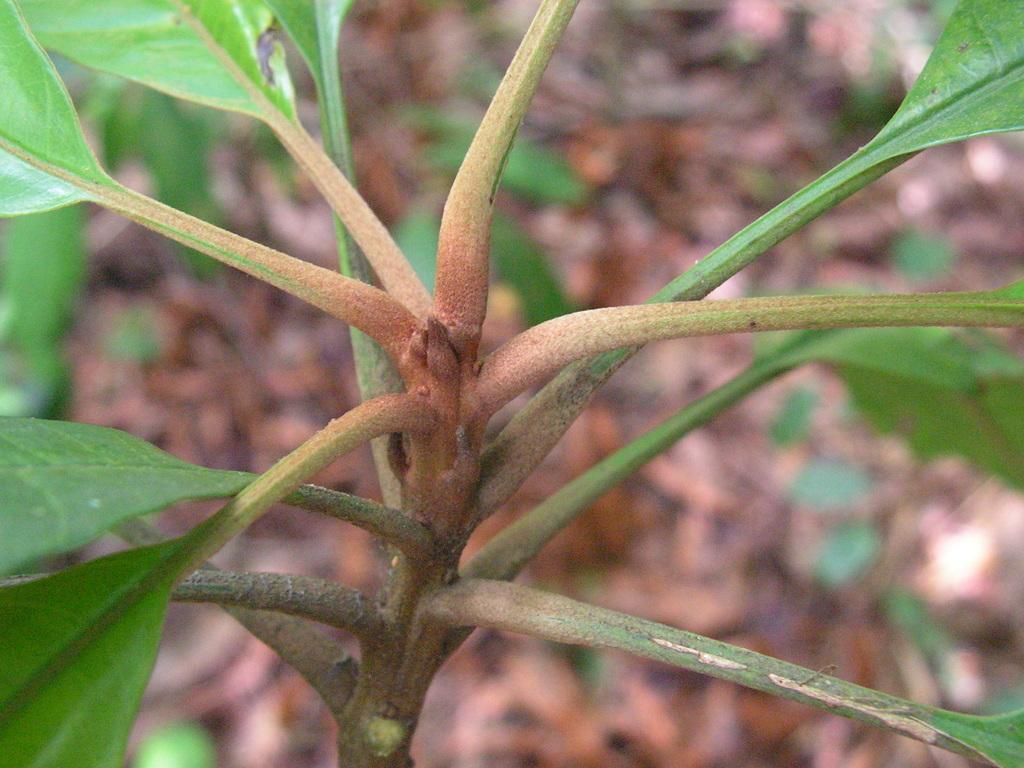In one or two sentences, can you explain what this image depicts? In the center of the image we can see plant. 